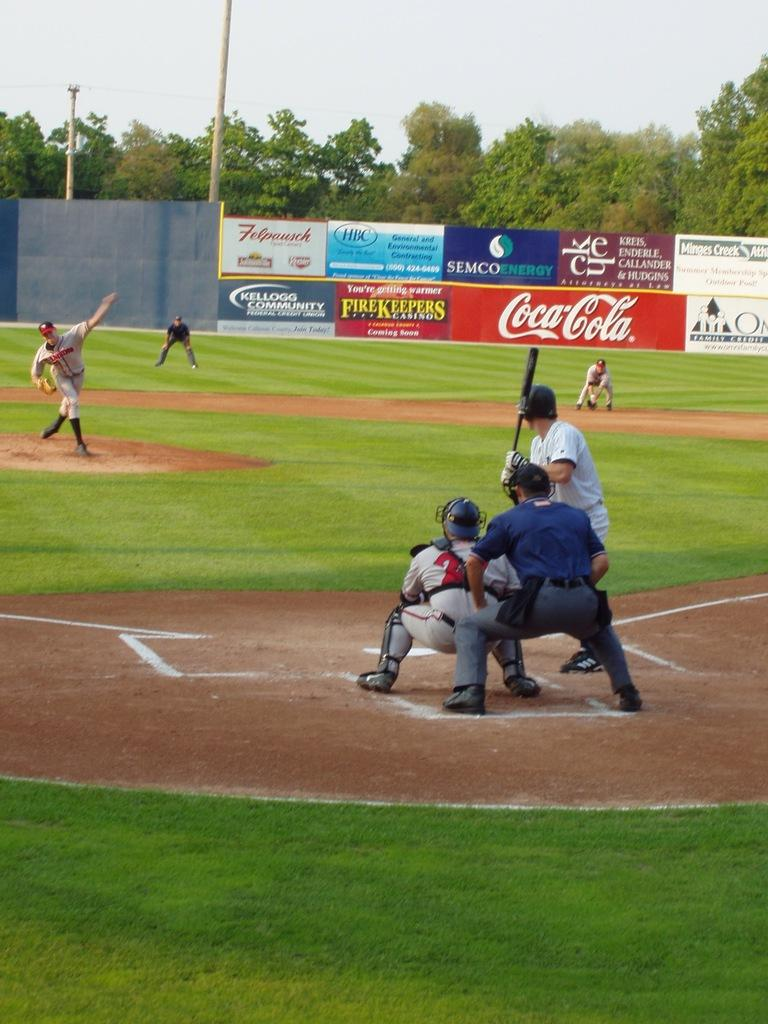<image>
Describe the image concisely. Coca Cola is one of the sponsors of this baseball field. 